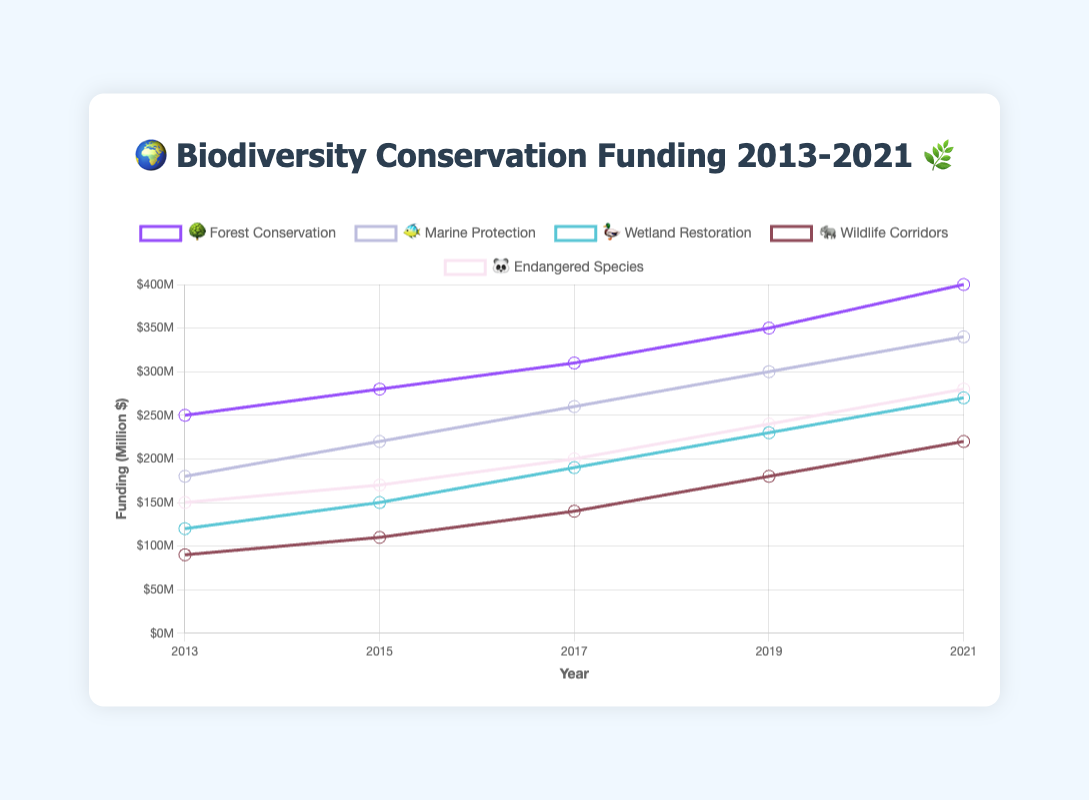What is the title of the chart? The title of the chart is found at the top and it is usually in a larger font. It states "🌍 Biodiversity Conservation Funding 2013-2021 🌿".
Answer: 🌍 Biodiversity Conservation Funding 2013-2021 🌿 Which type of conservation project received the highest funding in 2021? Look for the data point in the year 2021 and check which project has the highest funding value. "Forest Conservation" has a funding of $400M in 2021.
Answer: Forest Conservation What was the funding amount for Marine Protection 🐠 in 2015? Refer to the point on the Marine Protection line corresponding to the year 2015. The value is $220M.
Answer: $220M Compare the funding for Wetland Restoration 🦆 in 2013 and 2021. What is the difference? Find the funding values for Wetland Restoration in 2013 ($120M) and 2021 ($270M). Subtract the earlier year from the later year: $270M - $120M = $150M.
Answer: $150M Between 2017 and 2019, which conservation project showed the greatest increase in funding? Calculate the difference for each project between 2017 and 2019 and identify the maximum increase. "Wildlife Corridors" increased from $140M in 2017 to $180M in 2019, resulting in a $40M increase, which is the greatest.
Answer: Wildlife Corridors How much total funding was allocated across all projects in 2019? Sum up the funding amounts for all the projects in the year 2019: $350M (Forest) + $300M (Marine) + $230M (Wetland) + $180M (Wildlife) + $240M (Endangered) = $1300M.
Answer: $1300M Which project has the smallest funding amount in 2013? Identify the lowest funding value in 2013. "Wildlife Corridors" has the smallest funding with $90M.
Answer: Wildlife Corridors What is the average annual funding for Endangered Species 🐼 from 2013 to 2021? Add up all the funding amounts for Endangered Species from 2013 to 2021: $150M + $170M + $200M + $240M + $280M = $1040M. Then divide by the number of years, 1040/5 = $208M.
Answer: $208M 